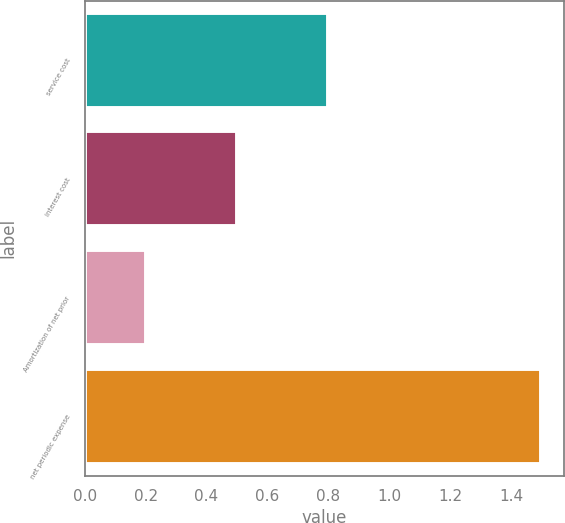Convert chart. <chart><loc_0><loc_0><loc_500><loc_500><bar_chart><fcel>service cost<fcel>interest cost<fcel>Amortization of net prior<fcel>net periodic expense<nl><fcel>0.8<fcel>0.5<fcel>0.2<fcel>1.5<nl></chart> 